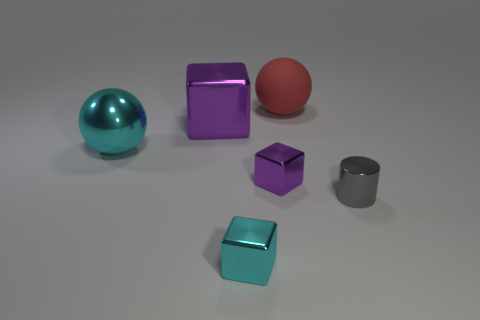Subtract all tiny cyan metal blocks. How many blocks are left? 2 Subtract 1 cubes. How many cubes are left? 2 Add 4 gray matte cubes. How many objects exist? 10 Subtract all cyan cubes. How many cubes are left? 2 Subtract all balls. How many objects are left? 4 Subtract all red cylinders. Subtract all brown spheres. How many cylinders are left? 1 Subtract all green cylinders. How many blue blocks are left? 0 Subtract all big rubber cylinders. Subtract all big cyan objects. How many objects are left? 5 Add 5 big cyan metallic spheres. How many big cyan metallic spheres are left? 6 Add 6 large rubber things. How many large rubber things exist? 7 